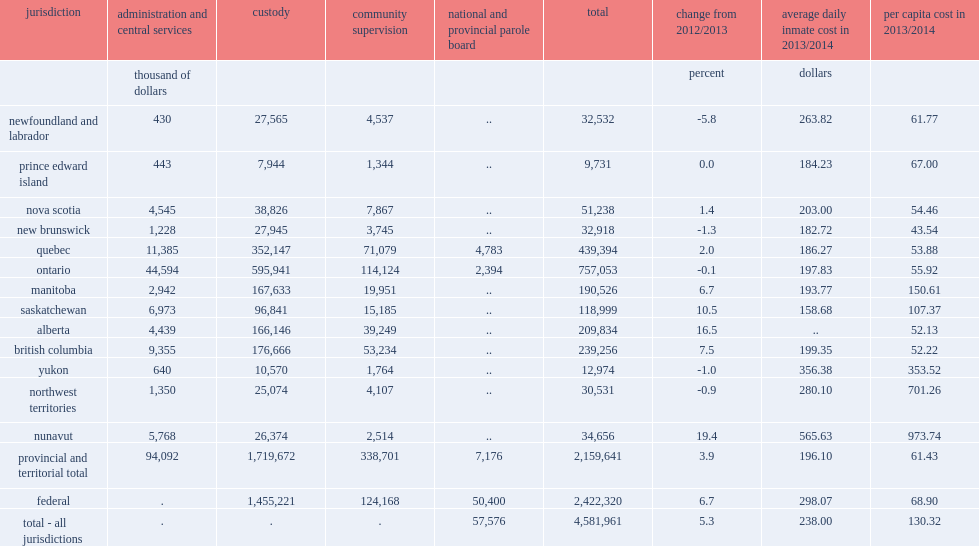In 2013/2014, what is the total operating expenditures for correctional services in canada? 4.581961. In 2013/2014, how many percent of total operating expenditures for correctional services in canada has increased from the previous year after adjusting for inflation? 5.3. What is the total operating expenditures for correctional services for each person in the canadian population? 130.32. Which sector has a higher total cost? federal adult correctional services or the provincial and territorial system? Federal. On average, in 2013/2014, what is the institutional expenditures per day for federal offenders? 298.07. On average, in 2013/2014, what is the institutional expenditures per day per provincial and territorial offenders? 196.1. I'm looking to parse the entire table for insights. Could you assist me with that? {'header': ['jurisdiction', 'administration and central services', 'custody', 'community supervision', 'national and provincial parole board', 'total', 'change from 2012/2013', 'average daily inmate cost in 2013/2014', 'per capita cost in 2013/2014'], 'rows': [['', 'thousand of dollars', '', '', '', '', 'percent', 'dollars', ''], ['newfoundland and labrador', '430', '27,565', '4,537', '..', '32,532', '-5.8', '263.82', '61.77'], ['prince edward island', '443', '7,944', '1,344', '..', '9,731', '0.0', '184.23', '67.00'], ['nova scotia', '4,545', '38,826', '7,867', '..', '51,238', '1.4', '203.00', '54.46'], ['new brunswick', '1,228', '27,945', '3,745', '..', '32,918', '-1.3', '182.72', '43.54'], ['quebec', '11,385', '352,147', '71,079', '4,783', '439,394', '2.0', '186.27', '53.88'], ['ontario', '44,594', '595,941', '114,124', '2,394', '757,053', '-0.1', '197.83', '55.92'], ['manitoba', '2,942', '167,633', '19,951', '..', '190,526', '6.7', '193.77', '150.61'], ['saskatchewan', '6,973', '96,841', '15,185', '..', '118,999', '10.5', '158.68', '107.37'], ['alberta', '4,439', '166,146', '39,249', '..', '209,834', '16.5', '..', '52.13'], ['british columbia', '9,355', '176,666', '53,234', '..', '239,256', '7.5', '199.35', '52.22'], ['yukon', '640', '10,570', '1,764', '..', '12,974', '-1.0', '356.38', '353.52'], ['northwest territories', '1,350', '25,074', '4,107', '..', '30,531', '-0.9', '280.10', '701.26'], ['nunavut', '5,768', '26,374', '2,514', '..', '34,656', '19.4', '565.63', '973.74'], ['provincial and territorial total', '94,092', '1,719,672', '338,701', '7,176', '2,159,641', '3.9', '196.10', '61.43'], ['federal', '.', '1,455,221', '124,168', '50,400', '2,422,320', '6.7', '298.07', '68.90'], ['total - all jurisdictions', '.', '.', '.', '57,576', '4,581,961', '5.3', '238.00', '130.32']]} 